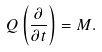Convert formula to latex. <formula><loc_0><loc_0><loc_500><loc_500>Q \left ( \frac { \partial } { \partial t } \right ) = M .</formula> 